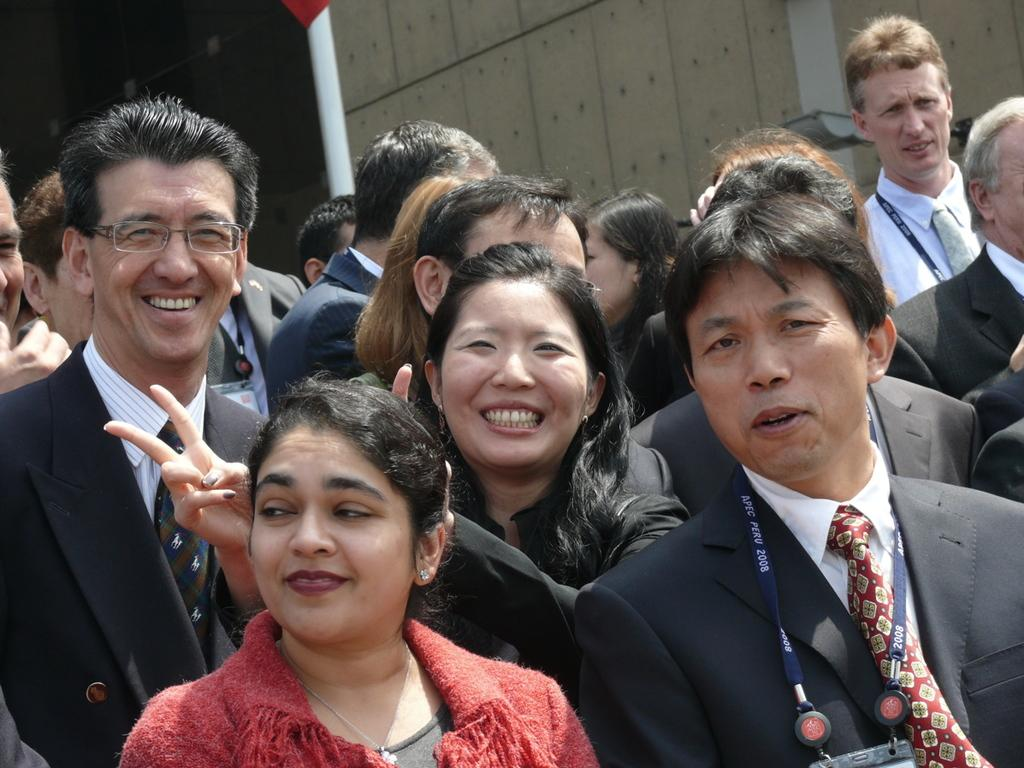How many people are in the image? There are people in the image, but the exact number is not specified. What type of clothing can be seen on some of the people? Some people are wearing coats and ties. What might be used for identification purposes in the image? Some people have ID cards. What can be seen in the background of the image? There is a pole and a wall in the background of the image. What type of cart is being used for learning in the image? There is no cart or learning activity present in the image. What is inside the box that is visible in the image? There is no box present in the image. 